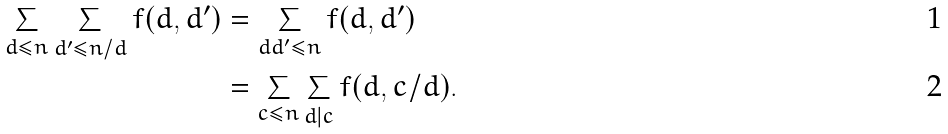Convert formula to latex. <formula><loc_0><loc_0><loc_500><loc_500>\sum _ { d \leq n } \sum _ { d ^ { \prime } \leq n / d } f ( d , d ^ { \prime } ) & = \sum _ { d d ^ { \prime } \leq n } f ( d , d ^ { \prime } ) \\ & = \sum _ { c \leq n } \sum _ { d | c } f ( d , c / d ) .</formula> 